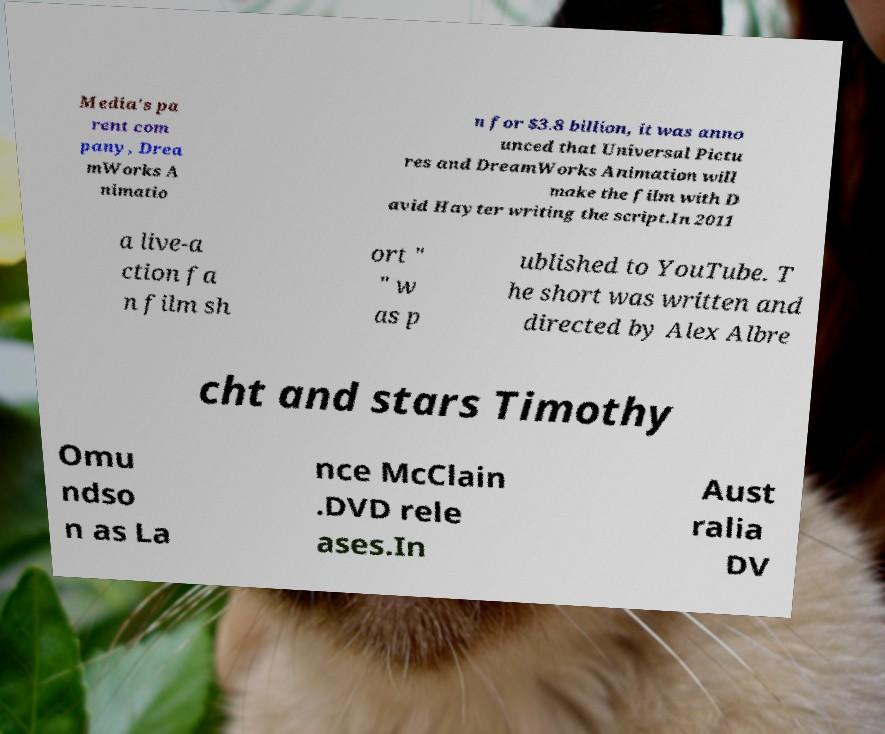There's text embedded in this image that I need extracted. Can you transcribe it verbatim? Media's pa rent com pany, Drea mWorks A nimatio n for $3.8 billion, it was anno unced that Universal Pictu res and DreamWorks Animation will make the film with D avid Hayter writing the script.In 2011 a live-a ction fa n film sh ort " " w as p ublished to YouTube. T he short was written and directed by Alex Albre cht and stars Timothy Omu ndso n as La nce McClain .DVD rele ases.In Aust ralia DV 